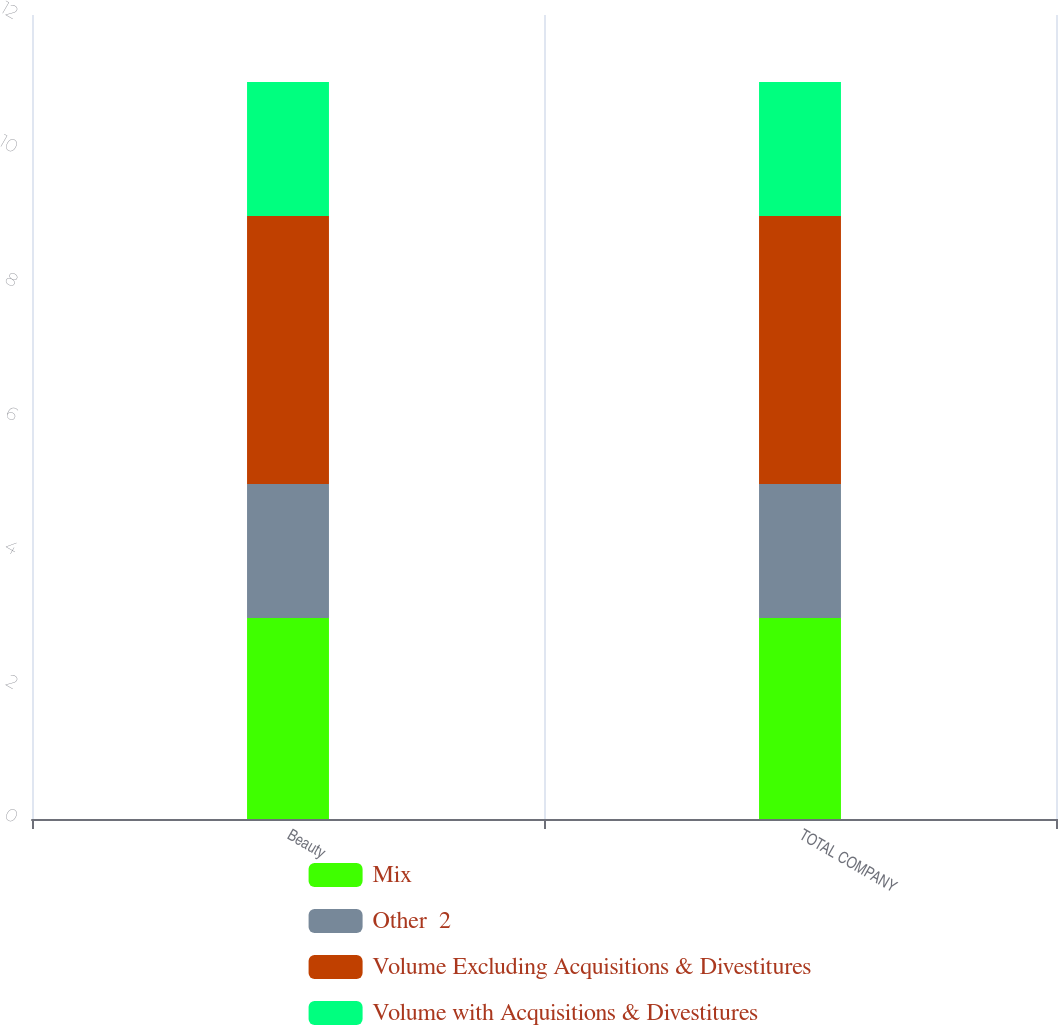<chart> <loc_0><loc_0><loc_500><loc_500><stacked_bar_chart><ecel><fcel>Beauty<fcel>TOTAL COMPANY<nl><fcel>Mix<fcel>3<fcel>3<nl><fcel>Other  2<fcel>2<fcel>2<nl><fcel>Volume Excluding Acquisitions & Divestitures<fcel>4<fcel>4<nl><fcel>Volume with Acquisitions & Divestitures<fcel>2<fcel>2<nl></chart> 